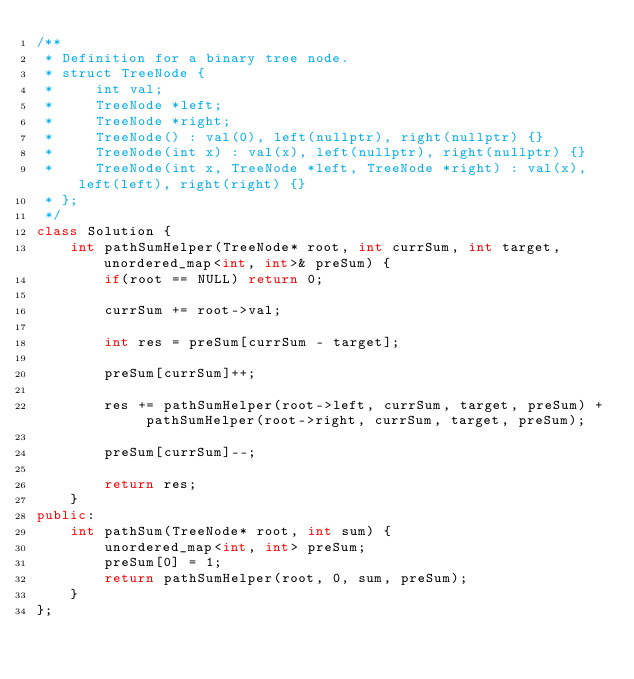<code> <loc_0><loc_0><loc_500><loc_500><_C++_>/**
 * Definition for a binary tree node.
 * struct TreeNode {
 *     int val;
 *     TreeNode *left;
 *     TreeNode *right;
 *     TreeNode() : val(0), left(nullptr), right(nullptr) {}
 *     TreeNode(int x) : val(x), left(nullptr), right(nullptr) {}
 *     TreeNode(int x, TreeNode *left, TreeNode *right) : val(x), left(left), right(right) {}
 * };
 */
class Solution {
    int pathSumHelper(TreeNode* root, int currSum, int target, unordered_map<int, int>& preSum) {
        if(root == NULL) return 0;
        
        currSum += root->val;
        
        int res = preSum[currSum - target];
        
        preSum[currSum]++;
        
        res += pathSumHelper(root->left, currSum, target, preSum) + pathSumHelper(root->right, currSum, target, preSum);
        
        preSum[currSum]--;
        
        return res;
    }
public:
    int pathSum(TreeNode* root, int sum) {
        unordered_map<int, int> preSum;
        preSum[0] = 1;
        return pathSumHelper(root, 0, sum, preSum);
    }
};</code> 